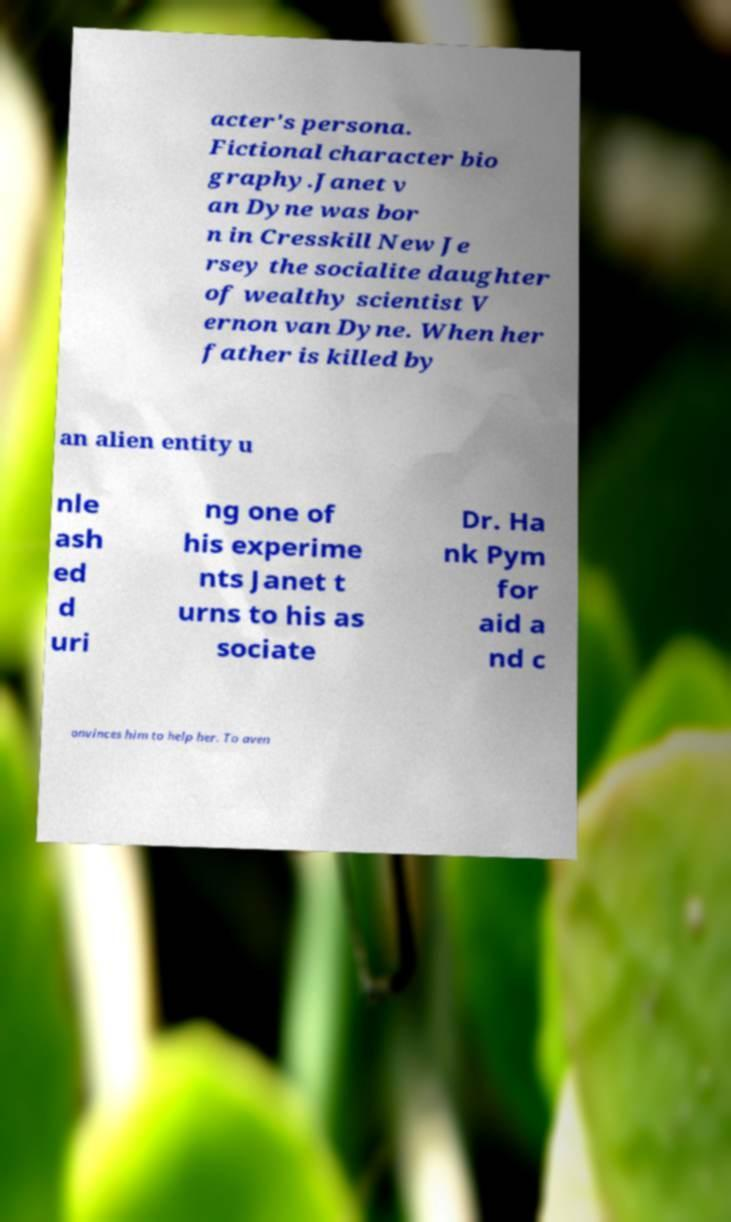Can you accurately transcribe the text from the provided image for me? acter's persona. Fictional character bio graphy.Janet v an Dyne was bor n in Cresskill New Je rsey the socialite daughter of wealthy scientist V ernon van Dyne. When her father is killed by an alien entity u nle ash ed d uri ng one of his experime nts Janet t urns to his as sociate Dr. Ha nk Pym for aid a nd c onvinces him to help her. To aven 